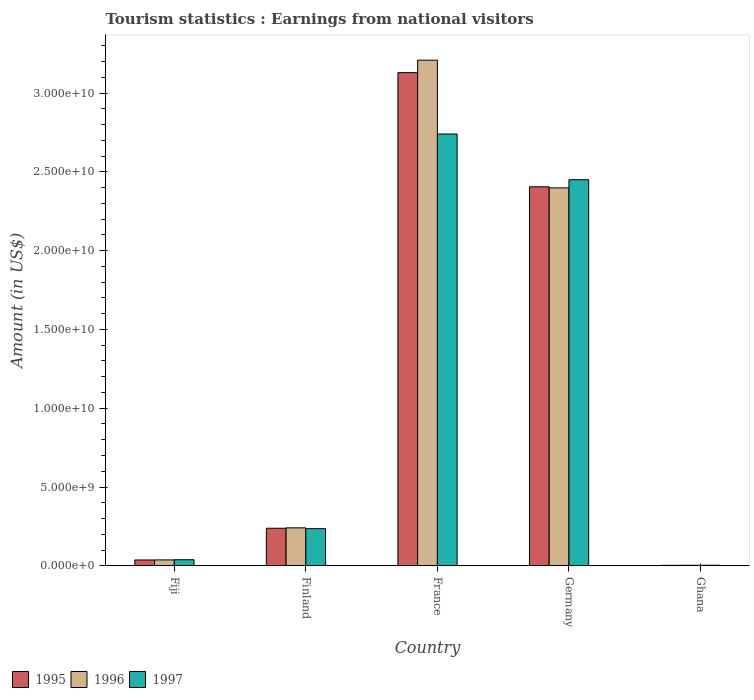How many different coloured bars are there?
Keep it short and to the point. 3. How many bars are there on the 4th tick from the left?
Your answer should be very brief. 3. How many bars are there on the 5th tick from the right?
Ensure brevity in your answer.  3. What is the label of the 2nd group of bars from the left?
Provide a short and direct response. Finland. In how many cases, is the number of bars for a given country not equal to the number of legend labels?
Your answer should be very brief. 0. What is the earnings from national visitors in 1997 in Ghana?
Your answer should be compact. 3.50e+07. Across all countries, what is the maximum earnings from national visitors in 1996?
Provide a short and direct response. 3.21e+1. Across all countries, what is the minimum earnings from national visitors in 1995?
Make the answer very short. 3.00e+07. In which country was the earnings from national visitors in 1995 minimum?
Your response must be concise. Ghana. What is the total earnings from national visitors in 1997 in the graph?
Your response must be concise. 5.47e+1. What is the difference between the earnings from national visitors in 1997 in Finland and that in Germany?
Ensure brevity in your answer.  -2.21e+1. What is the difference between the earnings from national visitors in 1996 in Germany and the earnings from national visitors in 1997 in Finland?
Your answer should be compact. 2.16e+1. What is the average earnings from national visitors in 1997 per country?
Your response must be concise. 1.09e+1. What is the difference between the earnings from national visitors of/in 1996 and earnings from national visitors of/in 1997 in Fiji?
Your answer should be very brief. -1.20e+07. In how many countries, is the earnings from national visitors in 1995 greater than 10000000000 US$?
Offer a very short reply. 2. What is the ratio of the earnings from national visitors in 1996 in Finland to that in Germany?
Keep it short and to the point. 0.1. Is the earnings from national visitors in 1996 in Fiji less than that in Finland?
Give a very brief answer. Yes. What is the difference between the highest and the second highest earnings from national visitors in 1997?
Give a very brief answer. 2.90e+09. What is the difference between the highest and the lowest earnings from national visitors in 1996?
Your answer should be compact. 3.21e+1. Is the sum of the earnings from national visitors in 1996 in Fiji and France greater than the maximum earnings from national visitors in 1997 across all countries?
Offer a terse response. Yes. What does the 3rd bar from the left in Fiji represents?
Offer a very short reply. 1997. What does the 1st bar from the right in Fiji represents?
Offer a terse response. 1997. Are all the bars in the graph horizontal?
Offer a very short reply. No. Are the values on the major ticks of Y-axis written in scientific E-notation?
Make the answer very short. Yes. Does the graph contain any zero values?
Offer a very short reply. No. Where does the legend appear in the graph?
Make the answer very short. Bottom left. How many legend labels are there?
Your response must be concise. 3. What is the title of the graph?
Provide a succinct answer. Tourism statistics : Earnings from national visitors. Does "1986" appear as one of the legend labels in the graph?
Provide a short and direct response. No. What is the label or title of the X-axis?
Ensure brevity in your answer.  Country. What is the label or title of the Y-axis?
Your answer should be very brief. Amount (in US$). What is the Amount (in US$) in 1995 in Fiji?
Offer a terse response. 3.69e+08. What is the Amount (in US$) in 1996 in Fiji?
Keep it short and to the point. 3.74e+08. What is the Amount (in US$) of 1997 in Fiji?
Give a very brief answer. 3.86e+08. What is the Amount (in US$) of 1995 in Finland?
Offer a very short reply. 2.38e+09. What is the Amount (in US$) of 1996 in Finland?
Give a very brief answer. 2.41e+09. What is the Amount (in US$) in 1997 in Finland?
Provide a succinct answer. 2.36e+09. What is the Amount (in US$) in 1995 in France?
Provide a succinct answer. 3.13e+1. What is the Amount (in US$) of 1996 in France?
Give a very brief answer. 3.21e+1. What is the Amount (in US$) of 1997 in France?
Ensure brevity in your answer.  2.74e+1. What is the Amount (in US$) of 1995 in Germany?
Your answer should be compact. 2.41e+1. What is the Amount (in US$) in 1996 in Germany?
Offer a very short reply. 2.40e+1. What is the Amount (in US$) in 1997 in Germany?
Offer a terse response. 2.45e+1. What is the Amount (in US$) in 1995 in Ghana?
Offer a very short reply. 3.00e+07. What is the Amount (in US$) of 1996 in Ghana?
Provide a succinct answer. 3.20e+07. What is the Amount (in US$) of 1997 in Ghana?
Give a very brief answer. 3.50e+07. Across all countries, what is the maximum Amount (in US$) of 1995?
Offer a terse response. 3.13e+1. Across all countries, what is the maximum Amount (in US$) in 1996?
Your response must be concise. 3.21e+1. Across all countries, what is the maximum Amount (in US$) of 1997?
Keep it short and to the point. 2.74e+1. Across all countries, what is the minimum Amount (in US$) of 1995?
Give a very brief answer. 3.00e+07. Across all countries, what is the minimum Amount (in US$) of 1996?
Your answer should be very brief. 3.20e+07. Across all countries, what is the minimum Amount (in US$) of 1997?
Your answer should be very brief. 3.50e+07. What is the total Amount (in US$) in 1995 in the graph?
Offer a terse response. 5.81e+1. What is the total Amount (in US$) of 1996 in the graph?
Ensure brevity in your answer.  5.89e+1. What is the total Amount (in US$) of 1997 in the graph?
Make the answer very short. 5.47e+1. What is the difference between the Amount (in US$) of 1995 in Fiji and that in Finland?
Give a very brief answer. -2.01e+09. What is the difference between the Amount (in US$) of 1996 in Fiji and that in Finland?
Your answer should be compact. -2.03e+09. What is the difference between the Amount (in US$) of 1997 in Fiji and that in Finland?
Your response must be concise. -1.97e+09. What is the difference between the Amount (in US$) of 1995 in Fiji and that in France?
Ensure brevity in your answer.  -3.09e+1. What is the difference between the Amount (in US$) of 1996 in Fiji and that in France?
Give a very brief answer. -3.17e+1. What is the difference between the Amount (in US$) of 1997 in Fiji and that in France?
Your answer should be very brief. -2.70e+1. What is the difference between the Amount (in US$) in 1995 in Fiji and that in Germany?
Offer a terse response. -2.37e+1. What is the difference between the Amount (in US$) in 1996 in Fiji and that in Germany?
Your response must be concise. -2.36e+1. What is the difference between the Amount (in US$) of 1997 in Fiji and that in Germany?
Give a very brief answer. -2.41e+1. What is the difference between the Amount (in US$) of 1995 in Fiji and that in Ghana?
Offer a terse response. 3.39e+08. What is the difference between the Amount (in US$) of 1996 in Fiji and that in Ghana?
Your answer should be very brief. 3.42e+08. What is the difference between the Amount (in US$) in 1997 in Fiji and that in Ghana?
Offer a very short reply. 3.51e+08. What is the difference between the Amount (in US$) in 1995 in Finland and that in France?
Your answer should be very brief. -2.89e+1. What is the difference between the Amount (in US$) in 1996 in Finland and that in France?
Make the answer very short. -2.97e+1. What is the difference between the Amount (in US$) of 1997 in Finland and that in France?
Give a very brief answer. -2.50e+1. What is the difference between the Amount (in US$) of 1995 in Finland and that in Germany?
Ensure brevity in your answer.  -2.17e+1. What is the difference between the Amount (in US$) of 1996 in Finland and that in Germany?
Provide a succinct answer. -2.16e+1. What is the difference between the Amount (in US$) of 1997 in Finland and that in Germany?
Provide a short and direct response. -2.21e+1. What is the difference between the Amount (in US$) in 1995 in Finland and that in Ghana?
Offer a terse response. 2.35e+09. What is the difference between the Amount (in US$) of 1996 in Finland and that in Ghana?
Ensure brevity in your answer.  2.38e+09. What is the difference between the Amount (in US$) of 1997 in Finland and that in Ghana?
Your answer should be very brief. 2.32e+09. What is the difference between the Amount (in US$) in 1995 in France and that in Germany?
Your response must be concise. 7.24e+09. What is the difference between the Amount (in US$) of 1996 in France and that in Germany?
Offer a very short reply. 8.11e+09. What is the difference between the Amount (in US$) of 1997 in France and that in Germany?
Ensure brevity in your answer.  2.90e+09. What is the difference between the Amount (in US$) of 1995 in France and that in Ghana?
Keep it short and to the point. 3.13e+1. What is the difference between the Amount (in US$) of 1996 in France and that in Ghana?
Offer a very short reply. 3.21e+1. What is the difference between the Amount (in US$) of 1997 in France and that in Ghana?
Make the answer very short. 2.74e+1. What is the difference between the Amount (in US$) of 1995 in Germany and that in Ghana?
Give a very brief answer. 2.40e+1. What is the difference between the Amount (in US$) in 1996 in Germany and that in Ghana?
Your answer should be very brief. 2.40e+1. What is the difference between the Amount (in US$) in 1997 in Germany and that in Ghana?
Your answer should be compact. 2.45e+1. What is the difference between the Amount (in US$) of 1995 in Fiji and the Amount (in US$) of 1996 in Finland?
Offer a very short reply. -2.04e+09. What is the difference between the Amount (in US$) of 1995 in Fiji and the Amount (in US$) of 1997 in Finland?
Ensure brevity in your answer.  -1.99e+09. What is the difference between the Amount (in US$) of 1996 in Fiji and the Amount (in US$) of 1997 in Finland?
Provide a succinct answer. -1.98e+09. What is the difference between the Amount (in US$) of 1995 in Fiji and the Amount (in US$) of 1996 in France?
Provide a short and direct response. -3.17e+1. What is the difference between the Amount (in US$) of 1995 in Fiji and the Amount (in US$) of 1997 in France?
Offer a terse response. -2.70e+1. What is the difference between the Amount (in US$) of 1996 in Fiji and the Amount (in US$) of 1997 in France?
Ensure brevity in your answer.  -2.70e+1. What is the difference between the Amount (in US$) in 1995 in Fiji and the Amount (in US$) in 1996 in Germany?
Provide a succinct answer. -2.36e+1. What is the difference between the Amount (in US$) in 1995 in Fiji and the Amount (in US$) in 1997 in Germany?
Your answer should be very brief. -2.41e+1. What is the difference between the Amount (in US$) in 1996 in Fiji and the Amount (in US$) in 1997 in Germany?
Offer a very short reply. -2.41e+1. What is the difference between the Amount (in US$) of 1995 in Fiji and the Amount (in US$) of 1996 in Ghana?
Provide a succinct answer. 3.37e+08. What is the difference between the Amount (in US$) in 1995 in Fiji and the Amount (in US$) in 1997 in Ghana?
Your response must be concise. 3.34e+08. What is the difference between the Amount (in US$) of 1996 in Fiji and the Amount (in US$) of 1997 in Ghana?
Make the answer very short. 3.39e+08. What is the difference between the Amount (in US$) in 1995 in Finland and the Amount (in US$) in 1996 in France?
Give a very brief answer. -2.97e+1. What is the difference between the Amount (in US$) of 1995 in Finland and the Amount (in US$) of 1997 in France?
Give a very brief answer. -2.50e+1. What is the difference between the Amount (in US$) in 1996 in Finland and the Amount (in US$) in 1997 in France?
Provide a short and direct response. -2.50e+1. What is the difference between the Amount (in US$) of 1995 in Finland and the Amount (in US$) of 1996 in Germany?
Ensure brevity in your answer.  -2.16e+1. What is the difference between the Amount (in US$) of 1995 in Finland and the Amount (in US$) of 1997 in Germany?
Your response must be concise. -2.21e+1. What is the difference between the Amount (in US$) in 1996 in Finland and the Amount (in US$) in 1997 in Germany?
Offer a terse response. -2.21e+1. What is the difference between the Amount (in US$) of 1995 in Finland and the Amount (in US$) of 1996 in Ghana?
Offer a very short reply. 2.35e+09. What is the difference between the Amount (in US$) in 1995 in Finland and the Amount (in US$) in 1997 in Ghana?
Make the answer very short. 2.35e+09. What is the difference between the Amount (in US$) of 1996 in Finland and the Amount (in US$) of 1997 in Ghana?
Your response must be concise. 2.37e+09. What is the difference between the Amount (in US$) in 1995 in France and the Amount (in US$) in 1996 in Germany?
Your answer should be very brief. 7.31e+09. What is the difference between the Amount (in US$) in 1995 in France and the Amount (in US$) in 1997 in Germany?
Offer a terse response. 6.79e+09. What is the difference between the Amount (in US$) in 1996 in France and the Amount (in US$) in 1997 in Germany?
Provide a succinct answer. 7.59e+09. What is the difference between the Amount (in US$) in 1995 in France and the Amount (in US$) in 1996 in Ghana?
Your answer should be very brief. 3.13e+1. What is the difference between the Amount (in US$) of 1995 in France and the Amount (in US$) of 1997 in Ghana?
Provide a succinct answer. 3.13e+1. What is the difference between the Amount (in US$) in 1996 in France and the Amount (in US$) in 1997 in Ghana?
Offer a terse response. 3.21e+1. What is the difference between the Amount (in US$) in 1995 in Germany and the Amount (in US$) in 1996 in Ghana?
Ensure brevity in your answer.  2.40e+1. What is the difference between the Amount (in US$) of 1995 in Germany and the Amount (in US$) of 1997 in Ghana?
Make the answer very short. 2.40e+1. What is the difference between the Amount (in US$) of 1996 in Germany and the Amount (in US$) of 1997 in Ghana?
Make the answer very short. 2.39e+1. What is the average Amount (in US$) of 1995 per country?
Offer a very short reply. 1.16e+1. What is the average Amount (in US$) in 1996 per country?
Ensure brevity in your answer.  1.18e+1. What is the average Amount (in US$) in 1997 per country?
Give a very brief answer. 1.09e+1. What is the difference between the Amount (in US$) of 1995 and Amount (in US$) of 1996 in Fiji?
Provide a short and direct response. -5.00e+06. What is the difference between the Amount (in US$) of 1995 and Amount (in US$) of 1997 in Fiji?
Offer a very short reply. -1.70e+07. What is the difference between the Amount (in US$) in 1996 and Amount (in US$) in 1997 in Fiji?
Provide a succinct answer. -1.20e+07. What is the difference between the Amount (in US$) in 1995 and Amount (in US$) in 1996 in Finland?
Offer a very short reply. -2.50e+07. What is the difference between the Amount (in US$) in 1995 and Amount (in US$) in 1997 in Finland?
Offer a very short reply. 2.50e+07. What is the difference between the Amount (in US$) in 1996 and Amount (in US$) in 1997 in Finland?
Provide a succinct answer. 5.00e+07. What is the difference between the Amount (in US$) of 1995 and Amount (in US$) of 1996 in France?
Provide a short and direct response. -7.93e+08. What is the difference between the Amount (in US$) in 1995 and Amount (in US$) in 1997 in France?
Your answer should be compact. 3.89e+09. What is the difference between the Amount (in US$) of 1996 and Amount (in US$) of 1997 in France?
Your response must be concise. 4.69e+09. What is the difference between the Amount (in US$) of 1995 and Amount (in US$) of 1996 in Germany?
Ensure brevity in your answer.  7.00e+07. What is the difference between the Amount (in US$) in 1995 and Amount (in US$) in 1997 in Germany?
Your response must be concise. -4.49e+08. What is the difference between the Amount (in US$) in 1996 and Amount (in US$) in 1997 in Germany?
Make the answer very short. -5.19e+08. What is the difference between the Amount (in US$) in 1995 and Amount (in US$) in 1997 in Ghana?
Provide a short and direct response. -5.00e+06. What is the difference between the Amount (in US$) in 1996 and Amount (in US$) in 1997 in Ghana?
Your answer should be very brief. -3.00e+06. What is the ratio of the Amount (in US$) of 1995 in Fiji to that in Finland?
Your answer should be very brief. 0.15. What is the ratio of the Amount (in US$) in 1996 in Fiji to that in Finland?
Provide a short and direct response. 0.16. What is the ratio of the Amount (in US$) in 1997 in Fiji to that in Finland?
Give a very brief answer. 0.16. What is the ratio of the Amount (in US$) of 1995 in Fiji to that in France?
Offer a very short reply. 0.01. What is the ratio of the Amount (in US$) in 1996 in Fiji to that in France?
Offer a terse response. 0.01. What is the ratio of the Amount (in US$) of 1997 in Fiji to that in France?
Ensure brevity in your answer.  0.01. What is the ratio of the Amount (in US$) in 1995 in Fiji to that in Germany?
Ensure brevity in your answer.  0.02. What is the ratio of the Amount (in US$) in 1996 in Fiji to that in Germany?
Offer a very short reply. 0.02. What is the ratio of the Amount (in US$) of 1997 in Fiji to that in Germany?
Ensure brevity in your answer.  0.02. What is the ratio of the Amount (in US$) in 1995 in Fiji to that in Ghana?
Keep it short and to the point. 12.3. What is the ratio of the Amount (in US$) of 1996 in Fiji to that in Ghana?
Make the answer very short. 11.69. What is the ratio of the Amount (in US$) in 1997 in Fiji to that in Ghana?
Your answer should be compact. 11.03. What is the ratio of the Amount (in US$) in 1995 in Finland to that in France?
Offer a terse response. 0.08. What is the ratio of the Amount (in US$) in 1996 in Finland to that in France?
Your response must be concise. 0.07. What is the ratio of the Amount (in US$) of 1997 in Finland to that in France?
Your response must be concise. 0.09. What is the ratio of the Amount (in US$) of 1995 in Finland to that in Germany?
Offer a very short reply. 0.1. What is the ratio of the Amount (in US$) in 1996 in Finland to that in Germany?
Your answer should be compact. 0.1. What is the ratio of the Amount (in US$) in 1997 in Finland to that in Germany?
Keep it short and to the point. 0.1. What is the ratio of the Amount (in US$) in 1995 in Finland to that in Ghana?
Offer a terse response. 79.43. What is the ratio of the Amount (in US$) in 1996 in Finland to that in Ghana?
Keep it short and to the point. 75.25. What is the ratio of the Amount (in US$) of 1997 in Finland to that in Ghana?
Make the answer very short. 67.37. What is the ratio of the Amount (in US$) in 1995 in France to that in Germany?
Provide a short and direct response. 1.3. What is the ratio of the Amount (in US$) of 1996 in France to that in Germany?
Keep it short and to the point. 1.34. What is the ratio of the Amount (in US$) in 1997 in France to that in Germany?
Ensure brevity in your answer.  1.12. What is the ratio of the Amount (in US$) of 1995 in France to that in Ghana?
Give a very brief answer. 1043.17. What is the ratio of the Amount (in US$) in 1996 in France to that in Ghana?
Offer a very short reply. 1002.75. What is the ratio of the Amount (in US$) in 1997 in France to that in Ghana?
Provide a succinct answer. 782.91. What is the ratio of the Amount (in US$) in 1995 in Germany to that in Ghana?
Your response must be concise. 801.73. What is the ratio of the Amount (in US$) in 1996 in Germany to that in Ghana?
Give a very brief answer. 749.44. What is the ratio of the Amount (in US$) of 1997 in Germany to that in Ghana?
Give a very brief answer. 700.03. What is the difference between the highest and the second highest Amount (in US$) of 1995?
Make the answer very short. 7.24e+09. What is the difference between the highest and the second highest Amount (in US$) in 1996?
Keep it short and to the point. 8.11e+09. What is the difference between the highest and the second highest Amount (in US$) of 1997?
Offer a very short reply. 2.90e+09. What is the difference between the highest and the lowest Amount (in US$) in 1995?
Provide a succinct answer. 3.13e+1. What is the difference between the highest and the lowest Amount (in US$) of 1996?
Provide a short and direct response. 3.21e+1. What is the difference between the highest and the lowest Amount (in US$) in 1997?
Offer a very short reply. 2.74e+1. 